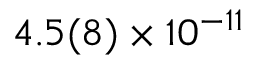Convert formula to latex. <formula><loc_0><loc_0><loc_500><loc_500>4 . 5 ( 8 ) \times 1 0 ^ { - 1 1 }</formula> 